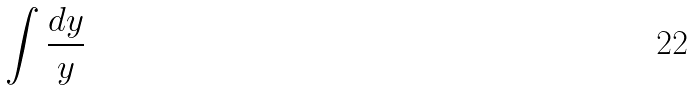Convert formula to latex. <formula><loc_0><loc_0><loc_500><loc_500>\int \frac { d y } { y }</formula> 